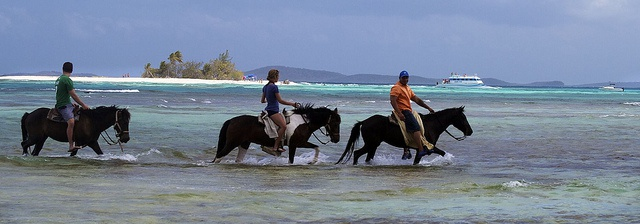Describe the objects in this image and their specific colors. I can see horse in gray, black, and darkgray tones, horse in gray, black, and darkgray tones, horse in gray and black tones, people in gray, black, maroon, and brown tones, and people in gray, black, maroon, and teal tones in this image. 